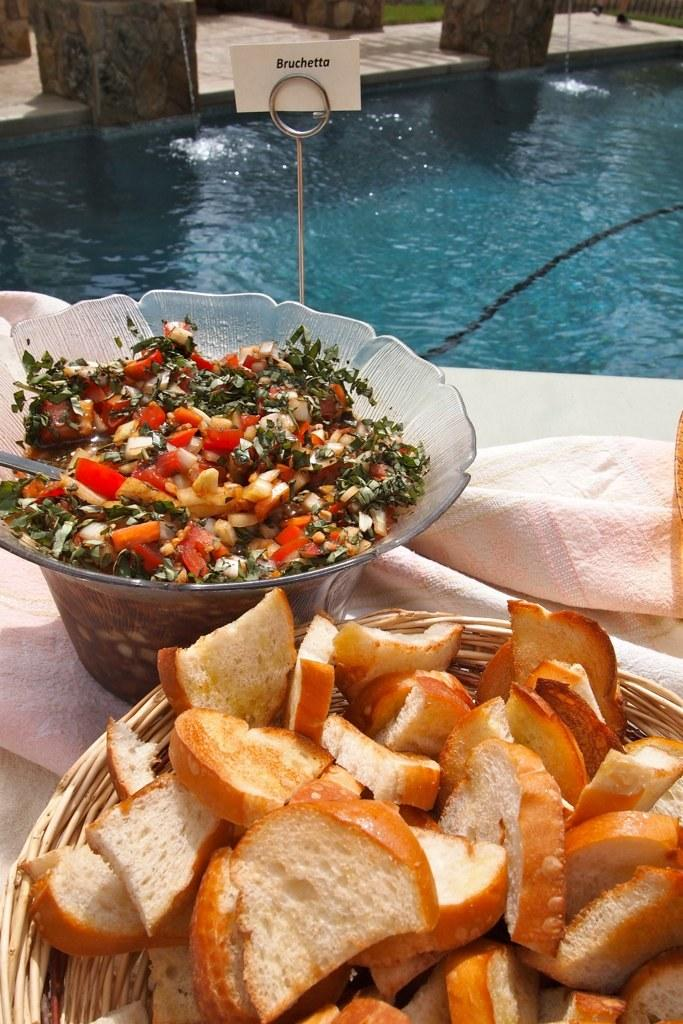What is in the bowls that are visible in the image? There is a group of bowls containing food in the image. Where are the bowls located in the image? The bowls are placed on a table in the image. What else can be seen on the table in the image? There is a cloth on the table in the image. What is on the stand in the image? There is a stand with a card on it in the image. What can be seen in the background of the image? Water is visible in the background of the image. What lesson is the group of students learning in the image? There are no students or lessons present in the image; it features a group of bowls containing food on a table. 